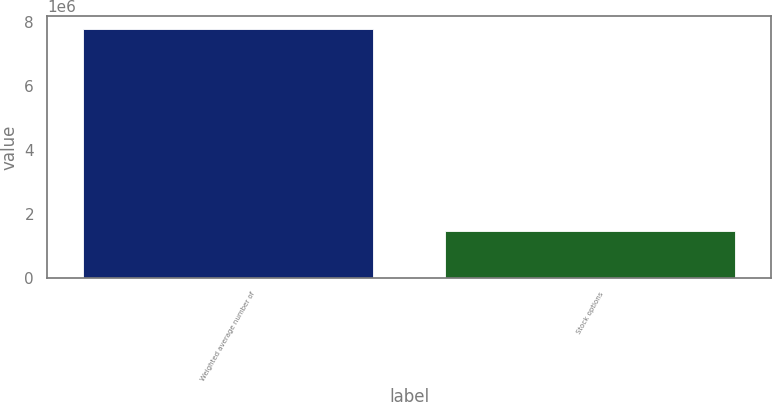<chart> <loc_0><loc_0><loc_500><loc_500><bar_chart><fcel>Weighted average number of<fcel>Stock options<nl><fcel>7.78438e+06<fcel>1.46353e+06<nl></chart> 